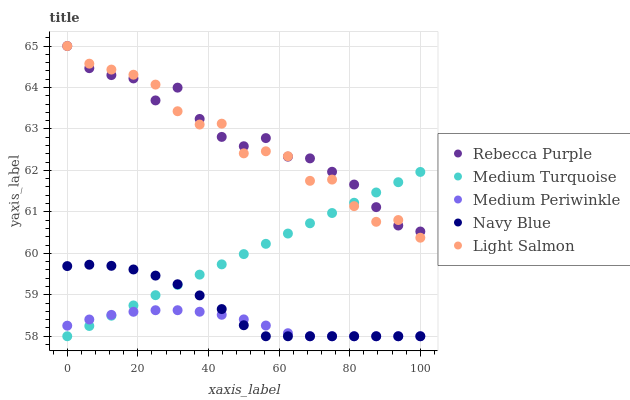Does Medium Periwinkle have the minimum area under the curve?
Answer yes or no. Yes. Does Rebecca Purple have the maximum area under the curve?
Answer yes or no. Yes. Does Light Salmon have the minimum area under the curve?
Answer yes or no. No. Does Light Salmon have the maximum area under the curve?
Answer yes or no. No. Is Medium Turquoise the smoothest?
Answer yes or no. Yes. Is Light Salmon the roughest?
Answer yes or no. Yes. Is Medium Periwinkle the smoothest?
Answer yes or no. No. Is Medium Periwinkle the roughest?
Answer yes or no. No. Does Navy Blue have the lowest value?
Answer yes or no. Yes. Does Light Salmon have the lowest value?
Answer yes or no. No. Does Rebecca Purple have the highest value?
Answer yes or no. Yes. Does Medium Periwinkle have the highest value?
Answer yes or no. No. Is Navy Blue less than Rebecca Purple?
Answer yes or no. Yes. Is Light Salmon greater than Medium Periwinkle?
Answer yes or no. Yes. Does Navy Blue intersect Medium Turquoise?
Answer yes or no. Yes. Is Navy Blue less than Medium Turquoise?
Answer yes or no. No. Is Navy Blue greater than Medium Turquoise?
Answer yes or no. No. Does Navy Blue intersect Rebecca Purple?
Answer yes or no. No. 